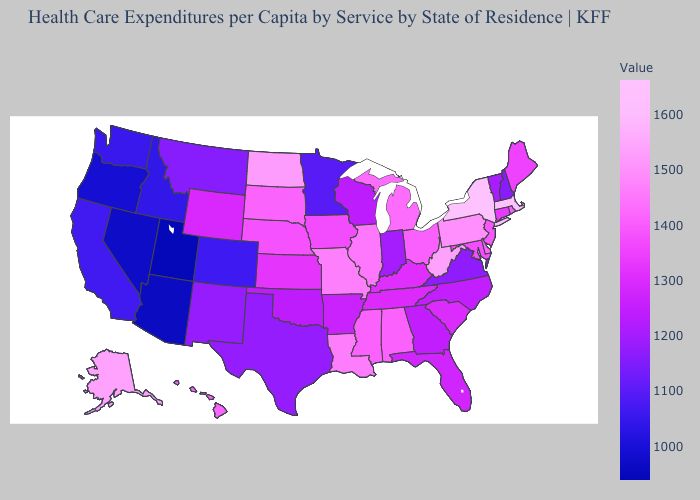Does Maine have the highest value in the Northeast?
Be succinct. No. Which states have the lowest value in the USA?
Write a very short answer. Utah. Does Kansas have the lowest value in the USA?
Give a very brief answer. No. Is the legend a continuous bar?
Write a very short answer. Yes. Does Georgia have the lowest value in the South?
Be succinct. No. Does Vermont have the highest value in the USA?
Concise answer only. No. Does Indiana have a higher value than Nevada?
Concise answer only. Yes. Which states have the lowest value in the USA?
Write a very short answer. Utah. Which states hav the highest value in the Northeast?
Write a very short answer. New York. 